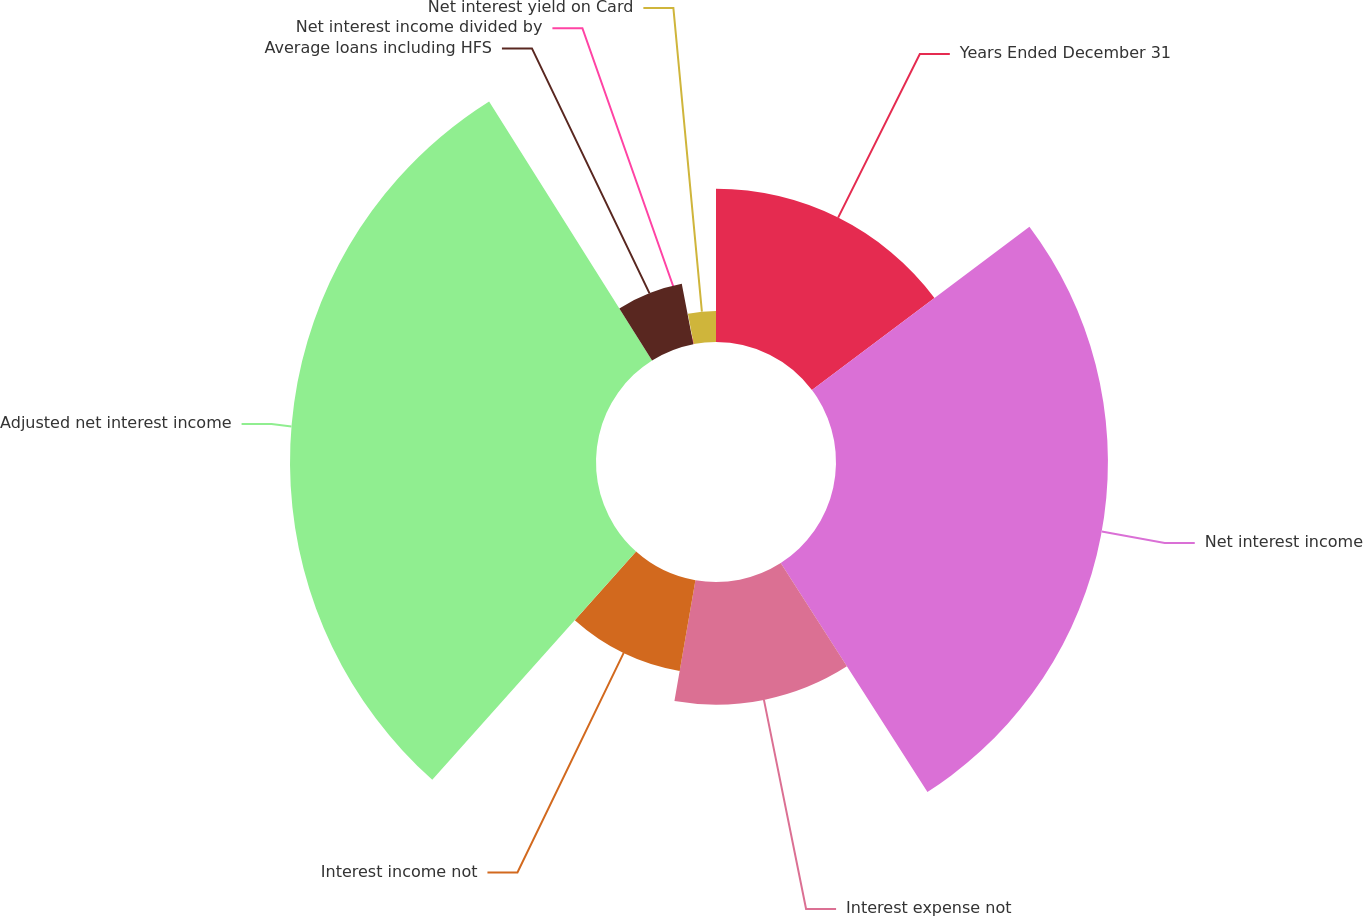Convert chart. <chart><loc_0><loc_0><loc_500><loc_500><pie_chart><fcel>Years Ended December 31<fcel>Net interest income<fcel>Interest expense not<fcel>Interest income not<fcel>Adjusted net interest income<fcel>Average loans including HFS<fcel>Net interest income divided by<fcel>Net interest yield on Card<nl><fcel>14.75%<fcel>26.18%<fcel>11.81%<fcel>8.86%<fcel>29.46%<fcel>5.92%<fcel>0.04%<fcel>2.98%<nl></chart> 